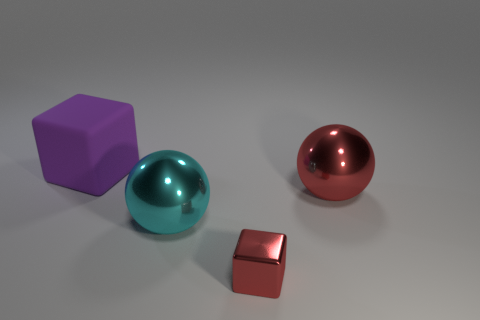How big is the ball right of the tiny red shiny cube?
Provide a short and direct response. Large. What size is the cyan thing?
Provide a short and direct response. Large. Is the size of the red sphere the same as the cube behind the cyan object?
Ensure brevity in your answer.  Yes. What color is the big ball that is to the left of the block that is right of the big purple matte block?
Give a very brief answer. Cyan. Are there an equal number of tiny red metal things that are to the right of the large red metal object and rubber blocks that are to the right of the red shiny cube?
Provide a succinct answer. Yes. Are the sphere that is on the left side of the small metallic thing and the big cube made of the same material?
Ensure brevity in your answer.  No. What is the color of the object that is in front of the big red shiny thing and behind the small red metallic block?
Make the answer very short. Cyan. There is a cube that is on the right side of the purple cube; what number of big purple rubber blocks are on the right side of it?
Give a very brief answer. 0. There is another large object that is the same shape as the big red metallic object; what is it made of?
Offer a very short reply. Metal. The metallic block is what color?
Keep it short and to the point. Red. 